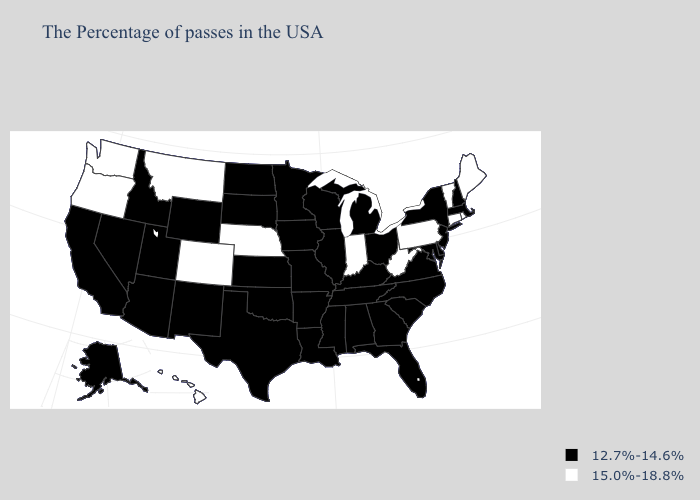Which states hav the highest value in the South?
Answer briefly. West Virginia. Does the first symbol in the legend represent the smallest category?
Answer briefly. Yes. What is the highest value in the Northeast ?
Keep it brief. 15.0%-18.8%. What is the highest value in states that border Nebraska?
Concise answer only. 15.0%-18.8%. What is the lowest value in the MidWest?
Answer briefly. 12.7%-14.6%. What is the value of Minnesota?
Be succinct. 12.7%-14.6%. Name the states that have a value in the range 12.7%-14.6%?
Give a very brief answer. Massachusetts, New Hampshire, New York, New Jersey, Delaware, Maryland, Virginia, North Carolina, South Carolina, Ohio, Florida, Georgia, Michigan, Kentucky, Alabama, Tennessee, Wisconsin, Illinois, Mississippi, Louisiana, Missouri, Arkansas, Minnesota, Iowa, Kansas, Oklahoma, Texas, South Dakota, North Dakota, Wyoming, New Mexico, Utah, Arizona, Idaho, Nevada, California, Alaska. How many symbols are there in the legend?
Write a very short answer. 2. Does Kansas have the highest value in the USA?
Give a very brief answer. No. Name the states that have a value in the range 15.0%-18.8%?
Write a very short answer. Maine, Rhode Island, Vermont, Connecticut, Pennsylvania, West Virginia, Indiana, Nebraska, Colorado, Montana, Washington, Oregon, Hawaii. What is the value of Tennessee?
Quick response, please. 12.7%-14.6%. What is the highest value in the USA?
Concise answer only. 15.0%-18.8%. Which states hav the highest value in the West?
Give a very brief answer. Colorado, Montana, Washington, Oregon, Hawaii. What is the highest value in states that border Montana?
Concise answer only. 12.7%-14.6%. 